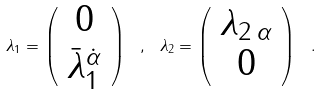Convert formula to latex. <formula><loc_0><loc_0><loc_500><loc_500>\lambda _ { 1 } = \left ( \begin{array} { c } 0 \\ \bar { \lambda } ^ { \dot { \alpha } } _ { 1 } \end{array} \right ) \ , \ \lambda _ { 2 } = \left ( \begin{array} { c } \lambda _ { 2 \, \alpha } \\ 0 \end{array} \right ) \ .</formula> 